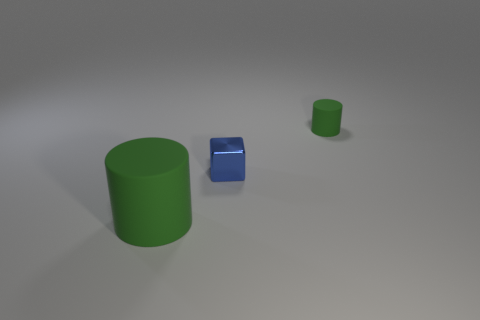There is a blue block left of the green matte thing behind the big cylinder to the left of the blue metal thing; how big is it? small 